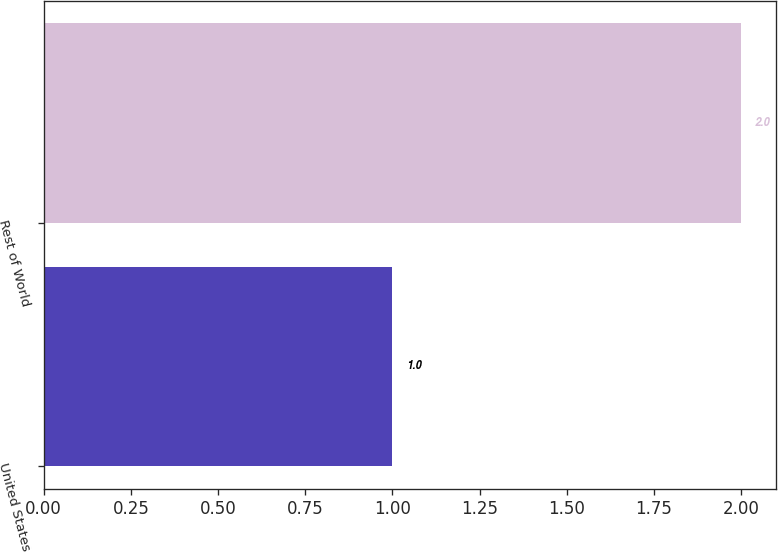<chart> <loc_0><loc_0><loc_500><loc_500><bar_chart><fcel>United States<fcel>Rest of World<nl><fcel>1<fcel>2<nl></chart> 